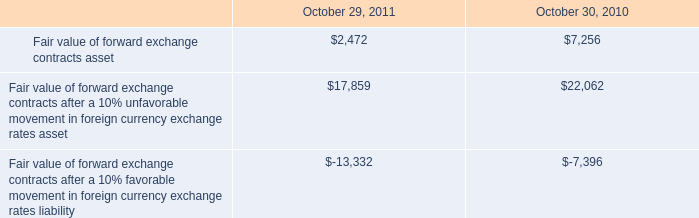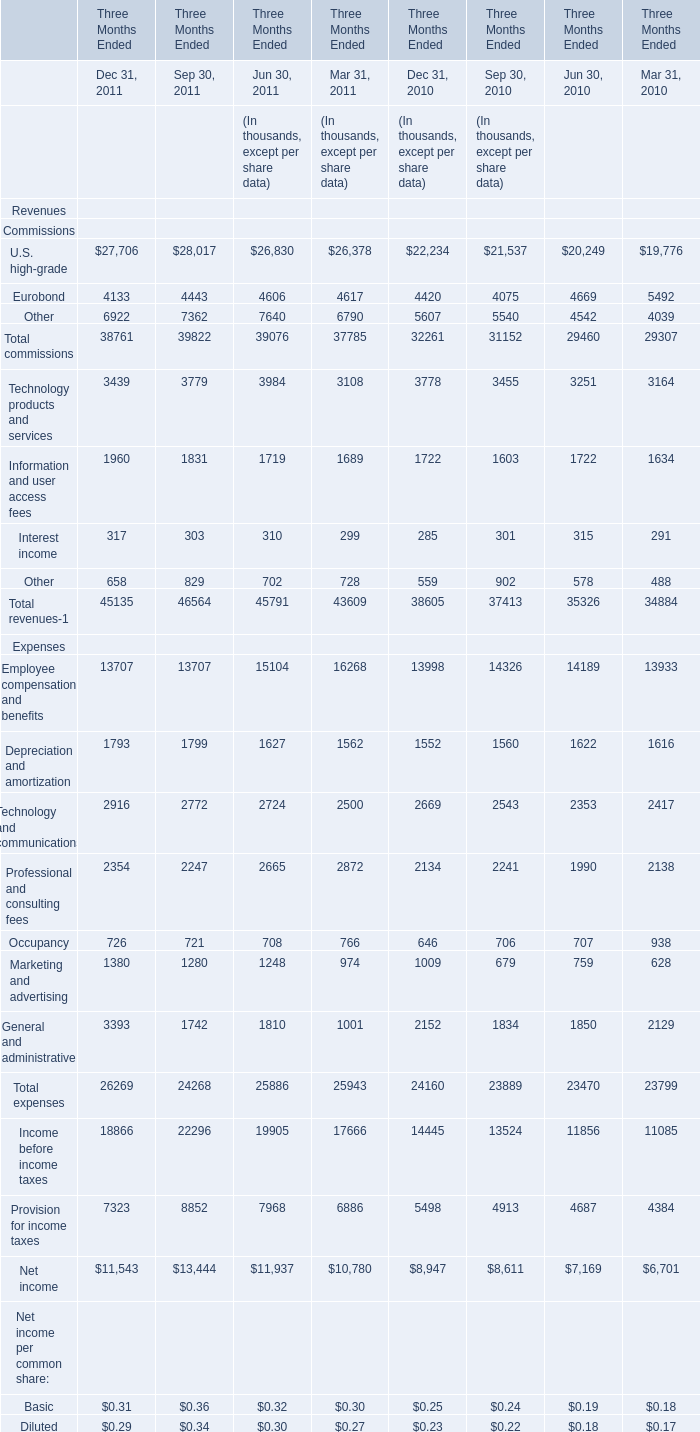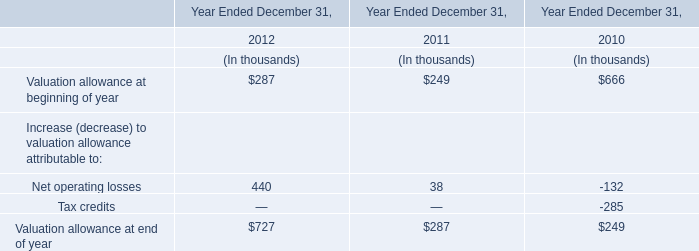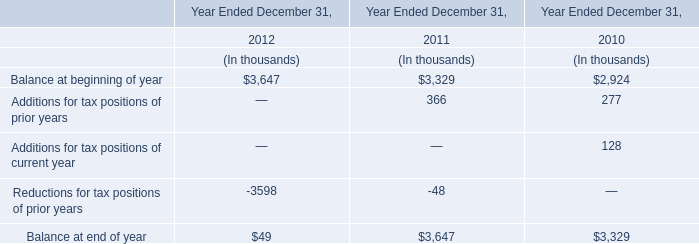what is the percentage change in fair value of forward exchange contracts asset from 2010 to 2011? 
Computations: ((2472 - 7256) / 7256)
Answer: -0.65932. 